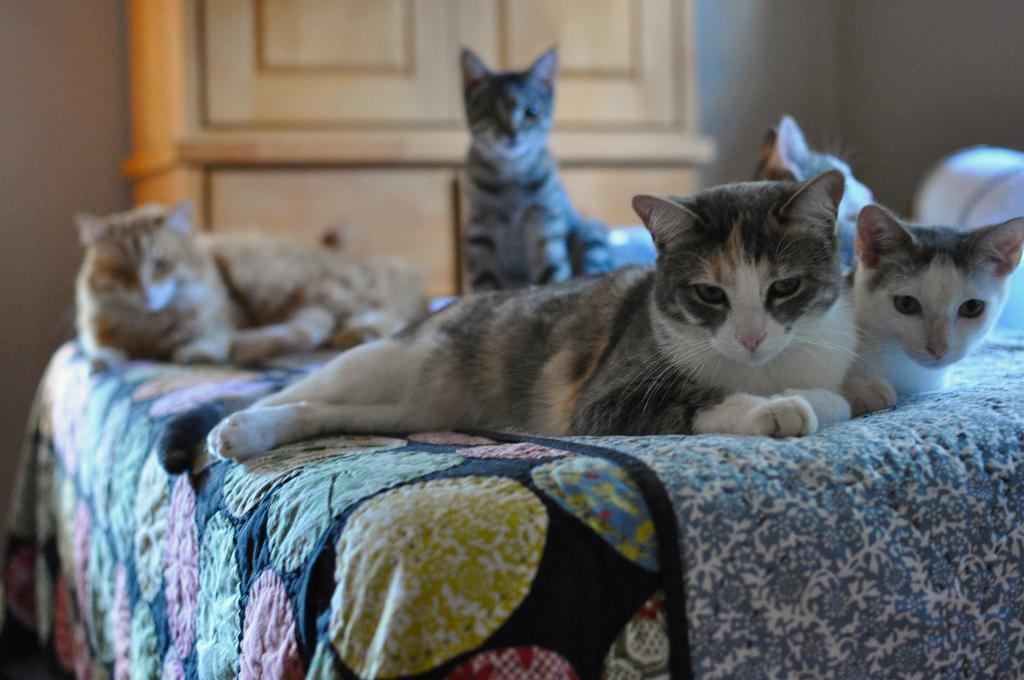What type of animals are on the bed in the image? There are cats on the bed in the image. What can be seen in the background of the image? There is a cupboard and a wall visible in the background of the image. What type of bead is used to create the alarm in the image? There is no bead or alarm present in the image. What type of smell can be detected in the image? The image does not provide any information about smells, so it cannot be determined from the image. 